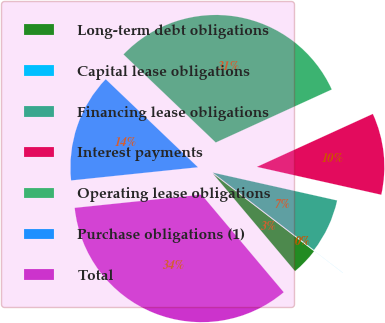Convert chart. <chart><loc_0><loc_0><loc_500><loc_500><pie_chart><fcel>Long-term debt obligations<fcel>Capital lease obligations<fcel>Financing lease obligations<fcel>Interest payments<fcel>Operating lease obligations<fcel>Purchase obligations (1)<fcel>Total<nl><fcel>3.45%<fcel>0.01%<fcel>6.89%<fcel>10.33%<fcel>31.05%<fcel>13.78%<fcel>34.49%<nl></chart> 